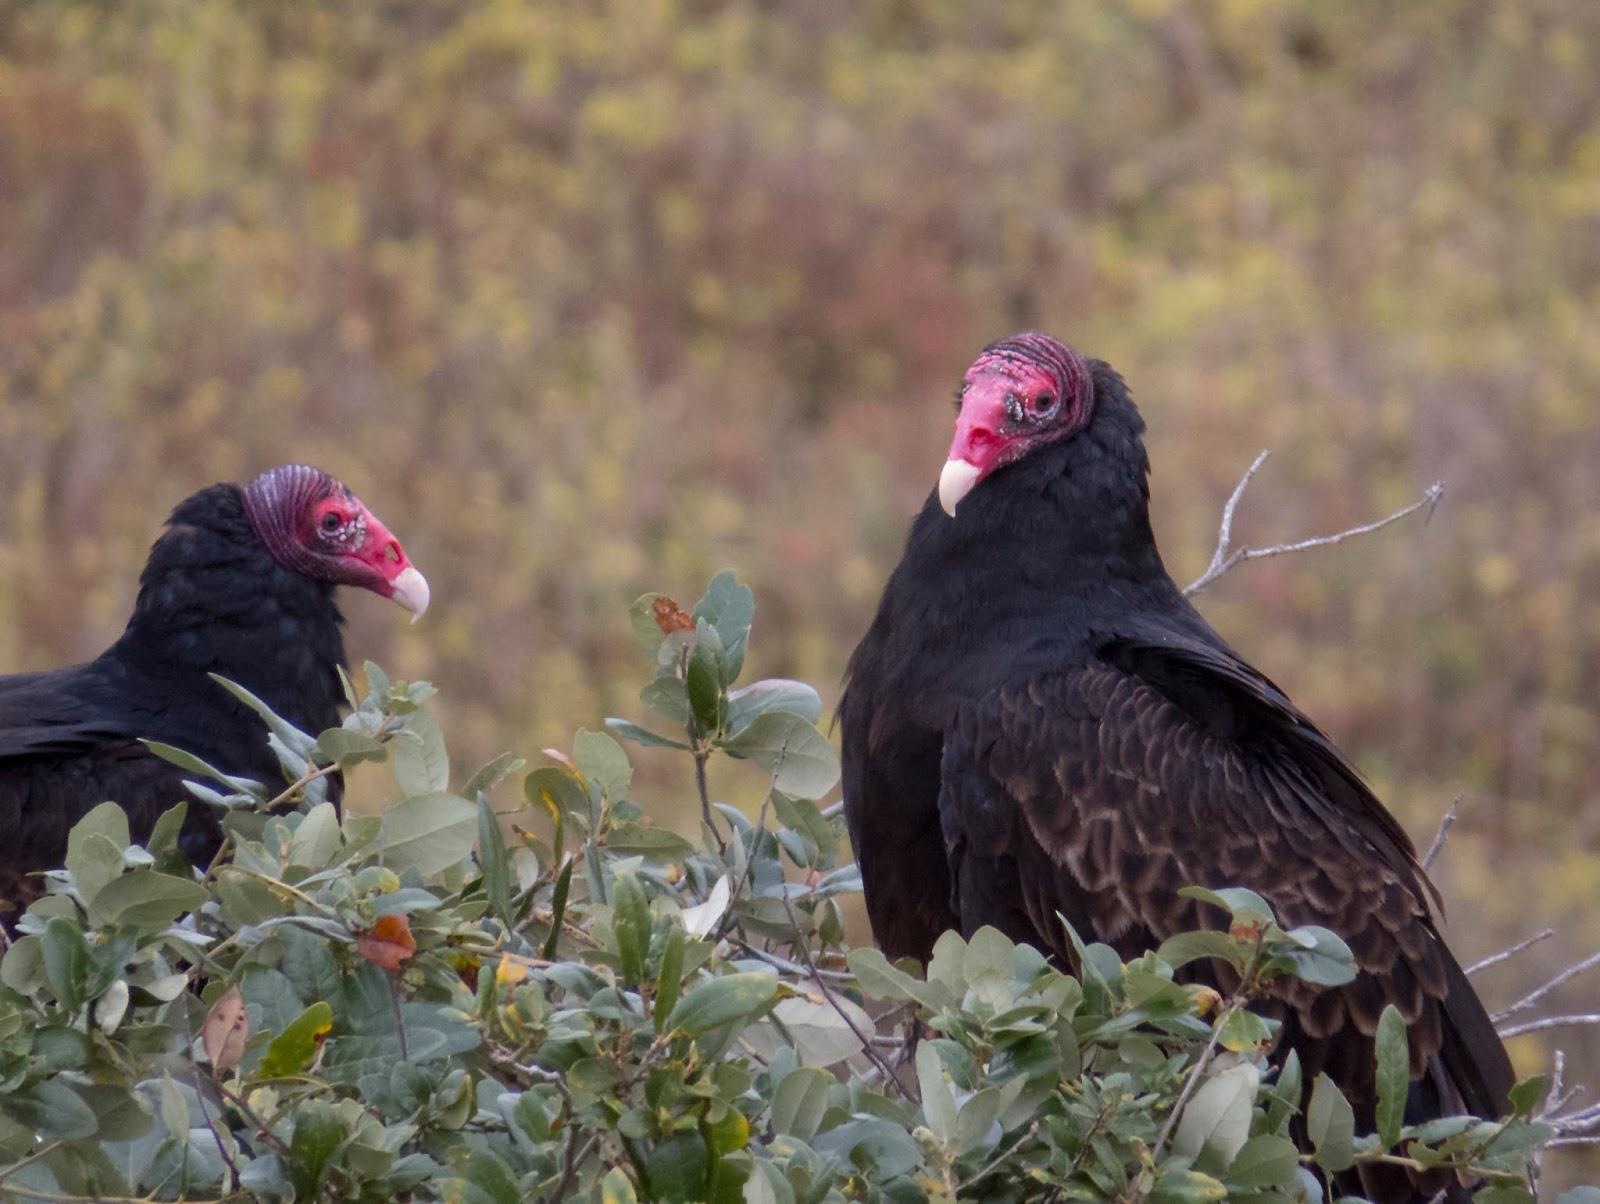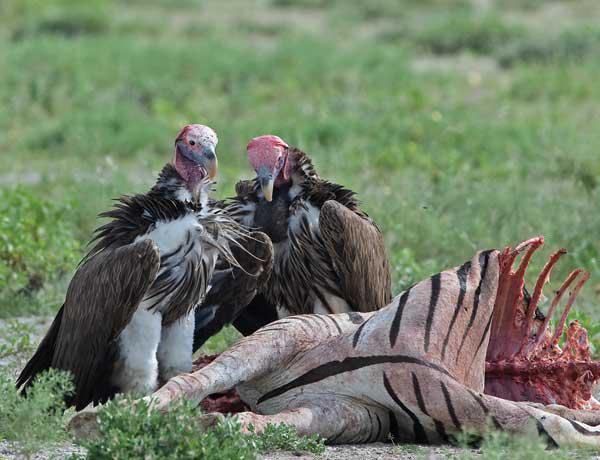The first image is the image on the left, the second image is the image on the right. Assess this claim about the two images: "There are more than four birds.". Correct or not? Answer yes or no. No. 